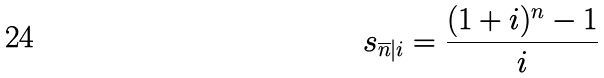<formula> <loc_0><loc_0><loc_500><loc_500>s _ { \overline { n } | i } = \frac { ( 1 + i ) ^ { n } - 1 } { i }</formula> 